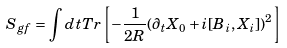<formula> <loc_0><loc_0><loc_500><loc_500>S _ { g f } = \int d t T r \left [ - \frac { 1 } { 2 R } ( \partial _ { t } X _ { 0 } + i [ B _ { i } , X _ { i } ] ) ^ { 2 } \right ]</formula> 